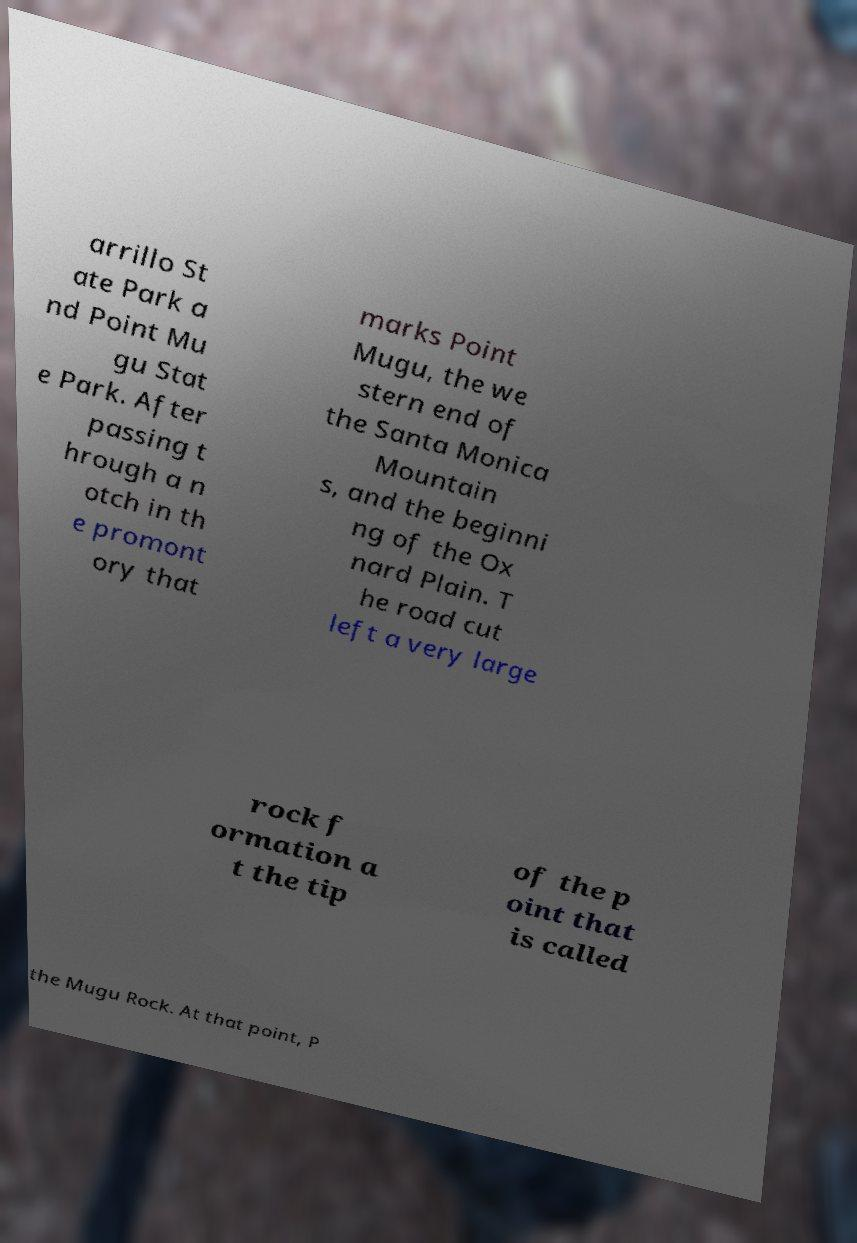I need the written content from this picture converted into text. Can you do that? arrillo St ate Park a nd Point Mu gu Stat e Park. After passing t hrough a n otch in th e promont ory that marks Point Mugu, the we stern end of the Santa Monica Mountain s, and the beginni ng of the Ox nard Plain. T he road cut left a very large rock f ormation a t the tip of the p oint that is called the Mugu Rock. At that point, P 